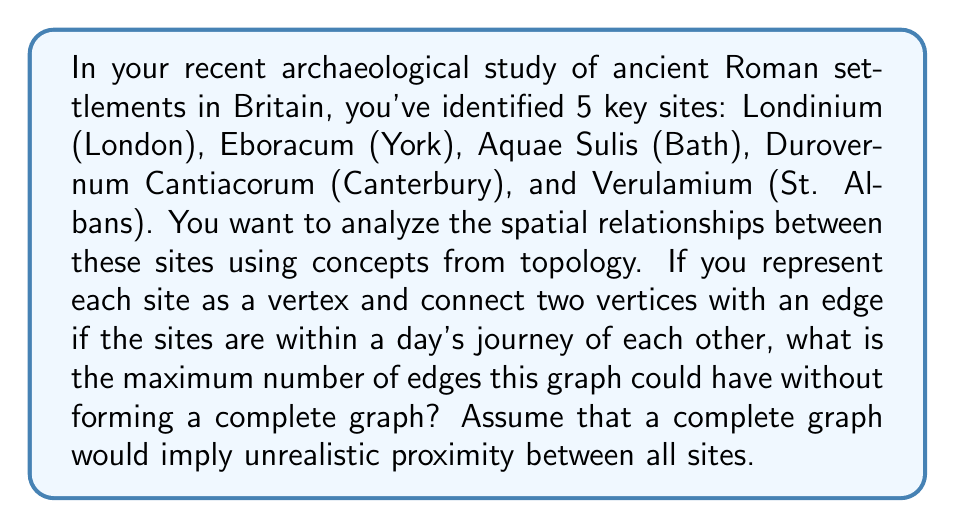Could you help me with this problem? Let's approach this step-by-step:

1) First, recall that in graph theory, a complete graph is one where every vertex is connected to every other vertex. For a graph with $n$ vertices, the number of edges in a complete graph is given by the formula:

   $$\binom{n}{2} = \frac{n(n-1)}{2}$$

2) In this case, we have 5 vertices (representing the 5 archaeological sites). If this were a complete graph, it would have:

   $$\binom{5}{2} = \frac{5(5-1)}{2} = \frac{5(4)}{2} = 10$$ edges

3) However, the question asks for the maximum number of edges without forming a complete graph. This means we need one less edge than a complete graph.

4) Therefore, the maximum number of edges without forming a complete graph is:

   $$10 - 1 = 9$$ edges

5) This configuration would represent a situation where all but one pair of sites are within a day's journey of each other, which is more realistic than all sites being that close to each other in Roman Britain.

[asy]
unitsize(1cm);
pair A = (0,0), B = (2,0), C = (1,1.732), D = (-1,1), E = (3,1);
draw(A--B--C--D--E--A--C, black);
draw(A--E, black);
draw(B--D, black);
dot(A); dot(B); dot(C); dot(D); dot(E);
label("Londinium", A, SW);
label("Eboracum", B, SE);
label("Aquae Sulis", C, N);
label("Durovernum", D, NW);
label("Verulamium", E, NE);
[/asy]

This diagram shows a possible configuration with 9 edges, where only one pair of sites (e.g., Londinium and Eboracum) are not directly connected.
Answer: 9 edges 